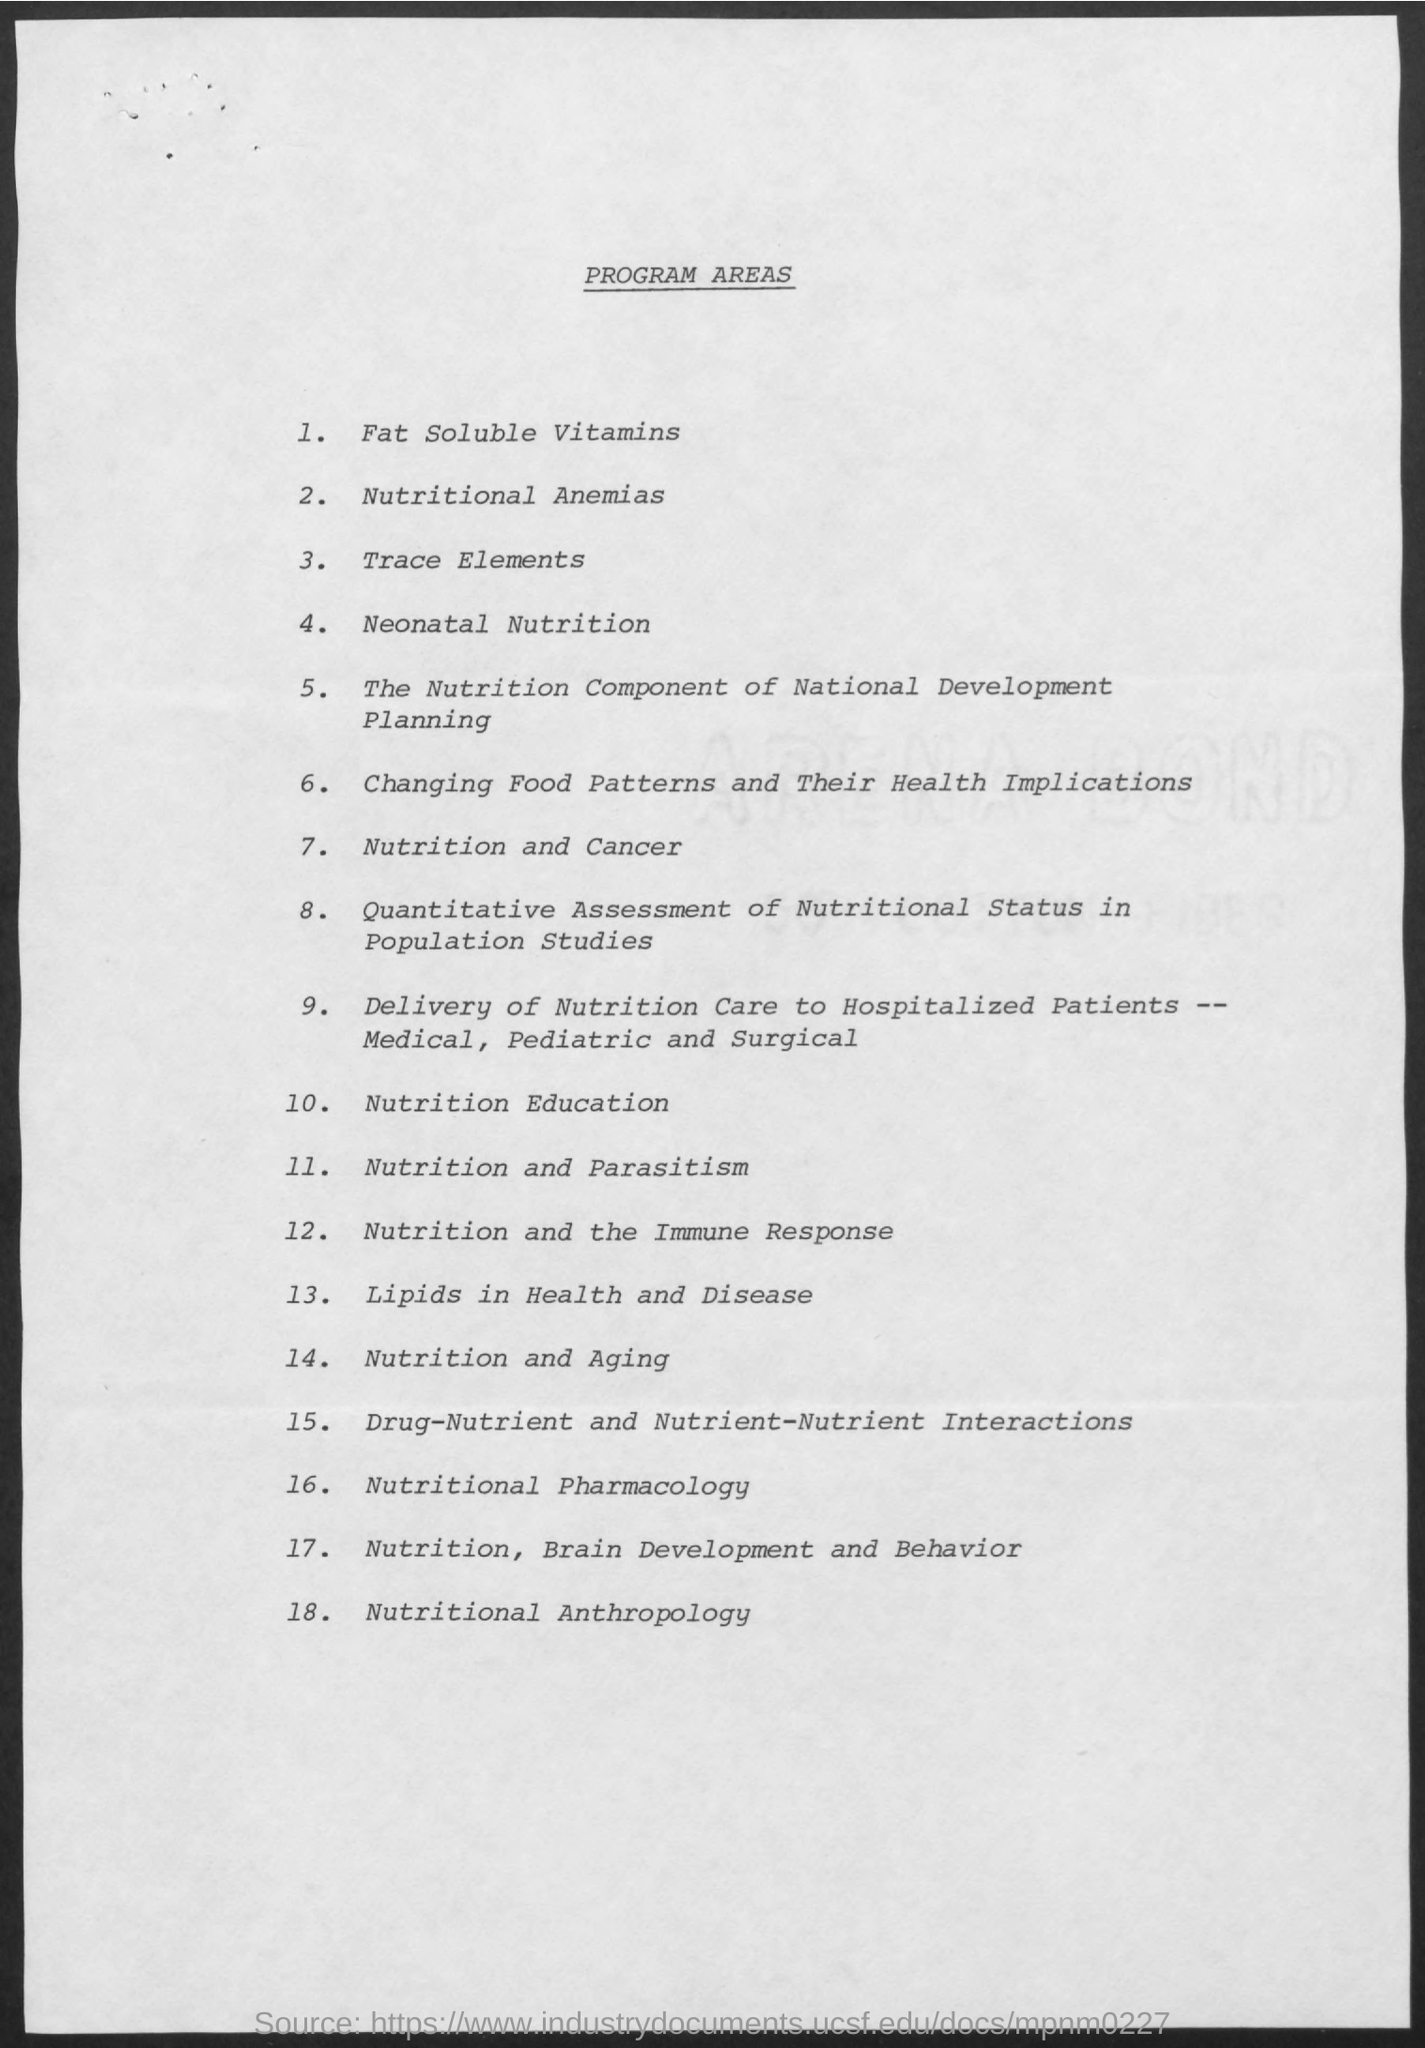What is the title of the document?
Your response must be concise. Program Areas. What is program area number 1 in the document?
Your response must be concise. Fat soluble vitamins. What is program area number 14 in the document?
Offer a very short reply. Nutrition and Aging. What is program area number 10 in the document?
Provide a short and direct response. Nutrition Education. What is program area number 3 in the document?
Your answer should be compact. Trace Elements. 